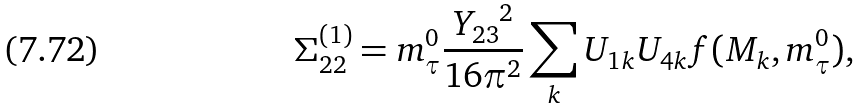<formula> <loc_0><loc_0><loc_500><loc_500>\Sigma ^ { ( 1 ) } _ { 2 2 } = m ^ { 0 } _ { \tau } \frac { { Y _ { 2 3 } } ^ { 2 } } { 1 6 \pi ^ { 2 } } \sum _ { k } { U _ { 1 k } U _ { 4 k } f ( M _ { k } , m ^ { 0 } _ { \tau } ) } ,</formula> 